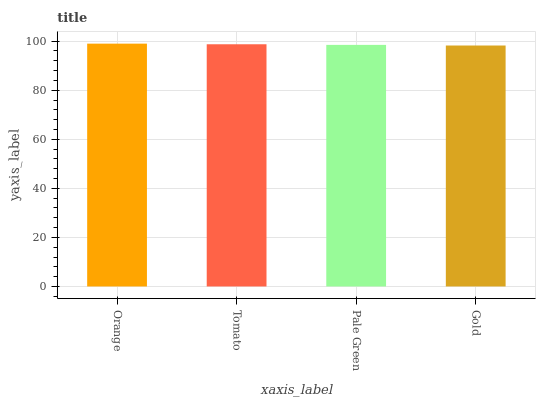Is Gold the minimum?
Answer yes or no. Yes. Is Orange the maximum?
Answer yes or no. Yes. Is Tomato the minimum?
Answer yes or no. No. Is Tomato the maximum?
Answer yes or no. No. Is Orange greater than Tomato?
Answer yes or no. Yes. Is Tomato less than Orange?
Answer yes or no. Yes. Is Tomato greater than Orange?
Answer yes or no. No. Is Orange less than Tomato?
Answer yes or no. No. Is Tomato the high median?
Answer yes or no. Yes. Is Pale Green the low median?
Answer yes or no. Yes. Is Pale Green the high median?
Answer yes or no. No. Is Gold the low median?
Answer yes or no. No. 